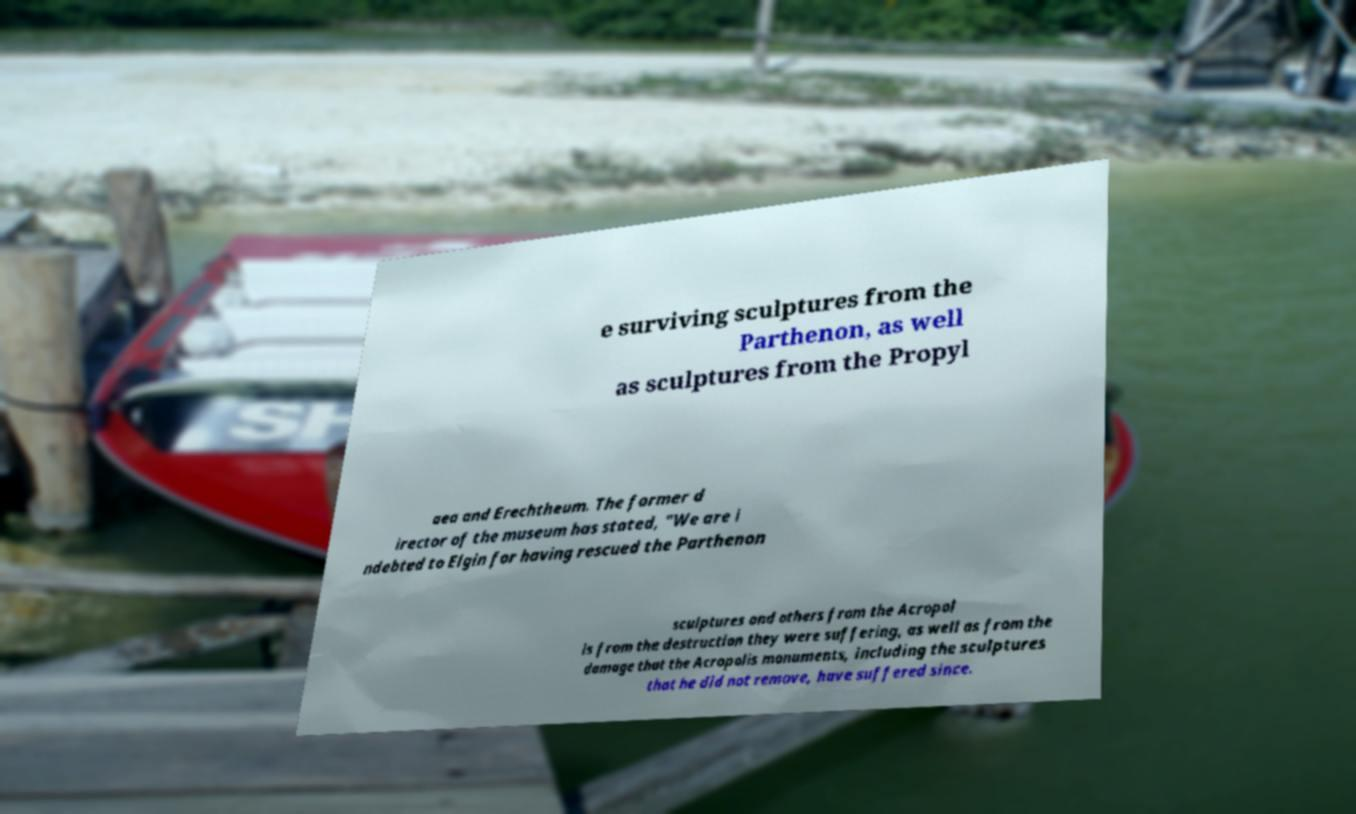Could you assist in decoding the text presented in this image and type it out clearly? e surviving sculptures from the Parthenon, as well as sculptures from the Propyl aea and Erechtheum. The former d irector of the museum has stated, "We are i ndebted to Elgin for having rescued the Parthenon sculptures and others from the Acropol is from the destruction they were suffering, as well as from the damage that the Acropolis monuments, including the sculptures that he did not remove, have suffered since. 